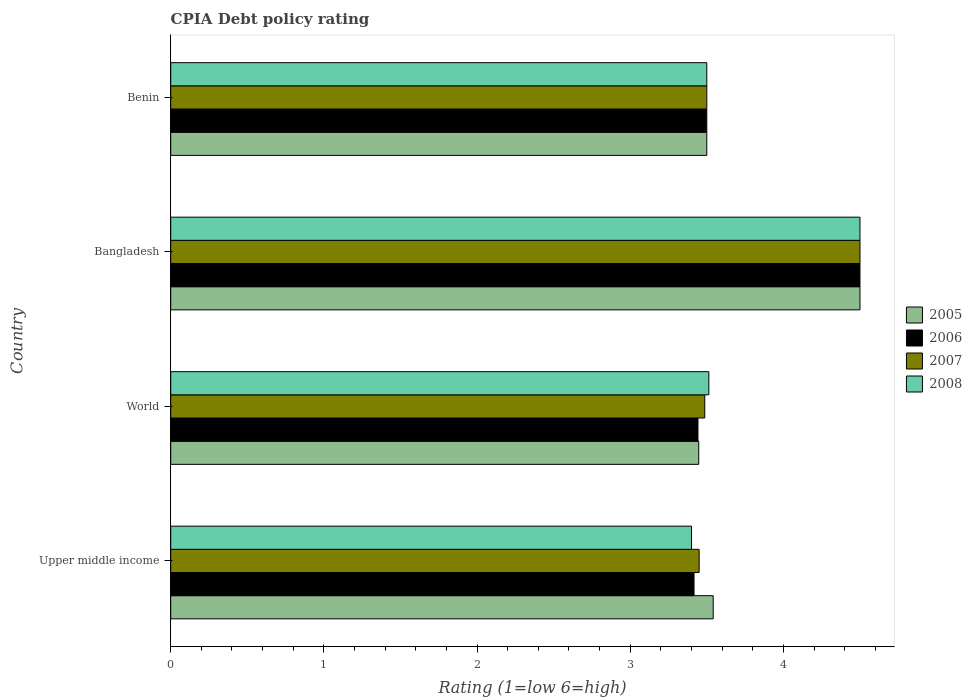How many groups of bars are there?
Provide a succinct answer. 4. Are the number of bars on each tick of the Y-axis equal?
Provide a succinct answer. Yes. What is the label of the 2nd group of bars from the top?
Keep it short and to the point. Bangladesh. What is the CPIA rating in 2007 in Benin?
Ensure brevity in your answer.  3.5. Across all countries, what is the maximum CPIA rating in 2005?
Offer a very short reply. 4.5. Across all countries, what is the minimum CPIA rating in 2007?
Provide a short and direct response. 3.45. In which country was the CPIA rating in 2007 minimum?
Provide a short and direct response. Upper middle income. What is the total CPIA rating in 2005 in the graph?
Provide a short and direct response. 14.99. What is the difference between the CPIA rating in 2005 in Upper middle income and that in World?
Keep it short and to the point. 0.09. What is the average CPIA rating in 2007 per country?
Your answer should be compact. 3.73. What is the difference between the CPIA rating in 2005 and CPIA rating in 2007 in Benin?
Ensure brevity in your answer.  0. What is the ratio of the CPIA rating in 2008 in Bangladesh to that in Benin?
Your answer should be very brief. 1.29. Is the difference between the CPIA rating in 2005 in Bangladesh and Benin greater than the difference between the CPIA rating in 2007 in Bangladesh and Benin?
Offer a very short reply. No. What is the difference between the highest and the second highest CPIA rating in 2008?
Provide a short and direct response. 0.99. What is the difference between the highest and the lowest CPIA rating in 2005?
Your response must be concise. 1.05. In how many countries, is the CPIA rating in 2007 greater than the average CPIA rating in 2007 taken over all countries?
Keep it short and to the point. 1. Is the sum of the CPIA rating in 2008 in Bangladesh and Upper middle income greater than the maximum CPIA rating in 2006 across all countries?
Give a very brief answer. Yes. What does the 1st bar from the top in Benin represents?
Provide a succinct answer. 2008. Is it the case that in every country, the sum of the CPIA rating in 2005 and CPIA rating in 2007 is greater than the CPIA rating in 2008?
Make the answer very short. Yes. How many bars are there?
Ensure brevity in your answer.  16. Are all the bars in the graph horizontal?
Give a very brief answer. Yes. How many countries are there in the graph?
Your response must be concise. 4. What is the difference between two consecutive major ticks on the X-axis?
Give a very brief answer. 1. Does the graph contain any zero values?
Give a very brief answer. No. Where does the legend appear in the graph?
Offer a terse response. Center right. How are the legend labels stacked?
Your answer should be compact. Vertical. What is the title of the graph?
Ensure brevity in your answer.  CPIA Debt policy rating. Does "2006" appear as one of the legend labels in the graph?
Make the answer very short. Yes. What is the Rating (1=low 6=high) of 2005 in Upper middle income?
Offer a very short reply. 3.54. What is the Rating (1=low 6=high) of 2006 in Upper middle income?
Make the answer very short. 3.42. What is the Rating (1=low 6=high) of 2007 in Upper middle income?
Your answer should be very brief. 3.45. What is the Rating (1=low 6=high) of 2005 in World?
Offer a terse response. 3.45. What is the Rating (1=low 6=high) of 2006 in World?
Keep it short and to the point. 3.44. What is the Rating (1=low 6=high) in 2007 in World?
Keep it short and to the point. 3.49. What is the Rating (1=low 6=high) of 2008 in World?
Provide a succinct answer. 3.51. What is the Rating (1=low 6=high) in 2005 in Bangladesh?
Your response must be concise. 4.5. What is the Rating (1=low 6=high) of 2006 in Bangladesh?
Keep it short and to the point. 4.5. What is the Rating (1=low 6=high) in 2007 in Bangladesh?
Your response must be concise. 4.5. What is the Rating (1=low 6=high) of 2005 in Benin?
Your answer should be very brief. 3.5. What is the Rating (1=low 6=high) of 2006 in Benin?
Provide a succinct answer. 3.5. What is the Rating (1=low 6=high) of 2008 in Benin?
Offer a terse response. 3.5. Across all countries, what is the minimum Rating (1=low 6=high) of 2005?
Your answer should be compact. 3.45. Across all countries, what is the minimum Rating (1=low 6=high) of 2006?
Your response must be concise. 3.42. Across all countries, what is the minimum Rating (1=low 6=high) of 2007?
Offer a very short reply. 3.45. What is the total Rating (1=low 6=high) of 2005 in the graph?
Make the answer very short. 14.99. What is the total Rating (1=low 6=high) of 2006 in the graph?
Provide a succinct answer. 14.86. What is the total Rating (1=low 6=high) of 2007 in the graph?
Your answer should be very brief. 14.94. What is the total Rating (1=low 6=high) in 2008 in the graph?
Offer a very short reply. 14.91. What is the difference between the Rating (1=low 6=high) of 2005 in Upper middle income and that in World?
Your answer should be compact. 0.09. What is the difference between the Rating (1=low 6=high) of 2006 in Upper middle income and that in World?
Offer a terse response. -0.03. What is the difference between the Rating (1=low 6=high) of 2007 in Upper middle income and that in World?
Your answer should be compact. -0.04. What is the difference between the Rating (1=low 6=high) in 2008 in Upper middle income and that in World?
Ensure brevity in your answer.  -0.11. What is the difference between the Rating (1=low 6=high) in 2005 in Upper middle income and that in Bangladesh?
Your answer should be very brief. -0.96. What is the difference between the Rating (1=low 6=high) of 2006 in Upper middle income and that in Bangladesh?
Give a very brief answer. -1.08. What is the difference between the Rating (1=low 6=high) of 2007 in Upper middle income and that in Bangladesh?
Offer a terse response. -1.05. What is the difference between the Rating (1=low 6=high) in 2008 in Upper middle income and that in Bangladesh?
Provide a short and direct response. -1.1. What is the difference between the Rating (1=low 6=high) in 2005 in Upper middle income and that in Benin?
Keep it short and to the point. 0.04. What is the difference between the Rating (1=low 6=high) in 2006 in Upper middle income and that in Benin?
Your answer should be very brief. -0.08. What is the difference between the Rating (1=low 6=high) in 2008 in Upper middle income and that in Benin?
Give a very brief answer. -0.1. What is the difference between the Rating (1=low 6=high) of 2005 in World and that in Bangladesh?
Keep it short and to the point. -1.05. What is the difference between the Rating (1=low 6=high) in 2006 in World and that in Bangladesh?
Your response must be concise. -1.06. What is the difference between the Rating (1=low 6=high) in 2007 in World and that in Bangladesh?
Offer a terse response. -1.01. What is the difference between the Rating (1=low 6=high) of 2008 in World and that in Bangladesh?
Provide a succinct answer. -0.99. What is the difference between the Rating (1=low 6=high) in 2005 in World and that in Benin?
Offer a terse response. -0.05. What is the difference between the Rating (1=low 6=high) of 2006 in World and that in Benin?
Offer a very short reply. -0.06. What is the difference between the Rating (1=low 6=high) in 2007 in World and that in Benin?
Ensure brevity in your answer.  -0.01. What is the difference between the Rating (1=low 6=high) in 2008 in World and that in Benin?
Your answer should be compact. 0.01. What is the difference between the Rating (1=low 6=high) in 2006 in Bangladesh and that in Benin?
Your answer should be compact. 1. What is the difference between the Rating (1=low 6=high) of 2008 in Bangladesh and that in Benin?
Provide a succinct answer. 1. What is the difference between the Rating (1=low 6=high) in 2005 in Upper middle income and the Rating (1=low 6=high) in 2006 in World?
Offer a terse response. 0.1. What is the difference between the Rating (1=low 6=high) of 2005 in Upper middle income and the Rating (1=low 6=high) of 2007 in World?
Provide a short and direct response. 0.06. What is the difference between the Rating (1=low 6=high) in 2005 in Upper middle income and the Rating (1=low 6=high) in 2008 in World?
Your answer should be compact. 0.03. What is the difference between the Rating (1=low 6=high) of 2006 in Upper middle income and the Rating (1=low 6=high) of 2007 in World?
Provide a succinct answer. -0.07. What is the difference between the Rating (1=low 6=high) in 2006 in Upper middle income and the Rating (1=low 6=high) in 2008 in World?
Provide a succinct answer. -0.1. What is the difference between the Rating (1=low 6=high) in 2007 in Upper middle income and the Rating (1=low 6=high) in 2008 in World?
Ensure brevity in your answer.  -0.06. What is the difference between the Rating (1=low 6=high) in 2005 in Upper middle income and the Rating (1=low 6=high) in 2006 in Bangladesh?
Provide a short and direct response. -0.96. What is the difference between the Rating (1=low 6=high) of 2005 in Upper middle income and the Rating (1=low 6=high) of 2007 in Bangladesh?
Your response must be concise. -0.96. What is the difference between the Rating (1=low 6=high) of 2005 in Upper middle income and the Rating (1=low 6=high) of 2008 in Bangladesh?
Provide a succinct answer. -0.96. What is the difference between the Rating (1=low 6=high) of 2006 in Upper middle income and the Rating (1=low 6=high) of 2007 in Bangladesh?
Offer a terse response. -1.08. What is the difference between the Rating (1=low 6=high) in 2006 in Upper middle income and the Rating (1=low 6=high) in 2008 in Bangladesh?
Offer a very short reply. -1.08. What is the difference between the Rating (1=low 6=high) of 2007 in Upper middle income and the Rating (1=low 6=high) of 2008 in Bangladesh?
Offer a very short reply. -1.05. What is the difference between the Rating (1=low 6=high) in 2005 in Upper middle income and the Rating (1=low 6=high) in 2006 in Benin?
Your answer should be very brief. 0.04. What is the difference between the Rating (1=low 6=high) of 2005 in Upper middle income and the Rating (1=low 6=high) of 2007 in Benin?
Ensure brevity in your answer.  0.04. What is the difference between the Rating (1=low 6=high) in 2005 in Upper middle income and the Rating (1=low 6=high) in 2008 in Benin?
Keep it short and to the point. 0.04. What is the difference between the Rating (1=low 6=high) of 2006 in Upper middle income and the Rating (1=low 6=high) of 2007 in Benin?
Your response must be concise. -0.08. What is the difference between the Rating (1=low 6=high) in 2006 in Upper middle income and the Rating (1=low 6=high) in 2008 in Benin?
Your answer should be very brief. -0.08. What is the difference between the Rating (1=low 6=high) in 2005 in World and the Rating (1=low 6=high) in 2006 in Bangladesh?
Your response must be concise. -1.05. What is the difference between the Rating (1=low 6=high) of 2005 in World and the Rating (1=low 6=high) of 2007 in Bangladesh?
Give a very brief answer. -1.05. What is the difference between the Rating (1=low 6=high) in 2005 in World and the Rating (1=low 6=high) in 2008 in Bangladesh?
Your answer should be very brief. -1.05. What is the difference between the Rating (1=low 6=high) of 2006 in World and the Rating (1=low 6=high) of 2007 in Bangladesh?
Keep it short and to the point. -1.06. What is the difference between the Rating (1=low 6=high) in 2006 in World and the Rating (1=low 6=high) in 2008 in Bangladesh?
Offer a terse response. -1.06. What is the difference between the Rating (1=low 6=high) in 2007 in World and the Rating (1=low 6=high) in 2008 in Bangladesh?
Offer a very short reply. -1.01. What is the difference between the Rating (1=low 6=high) of 2005 in World and the Rating (1=low 6=high) of 2006 in Benin?
Your answer should be compact. -0.05. What is the difference between the Rating (1=low 6=high) in 2005 in World and the Rating (1=low 6=high) in 2007 in Benin?
Offer a very short reply. -0.05. What is the difference between the Rating (1=low 6=high) of 2005 in World and the Rating (1=low 6=high) of 2008 in Benin?
Ensure brevity in your answer.  -0.05. What is the difference between the Rating (1=low 6=high) in 2006 in World and the Rating (1=low 6=high) in 2007 in Benin?
Keep it short and to the point. -0.06. What is the difference between the Rating (1=low 6=high) of 2006 in World and the Rating (1=low 6=high) of 2008 in Benin?
Provide a succinct answer. -0.06. What is the difference between the Rating (1=low 6=high) of 2007 in World and the Rating (1=low 6=high) of 2008 in Benin?
Your response must be concise. -0.01. What is the difference between the Rating (1=low 6=high) in 2005 in Bangladesh and the Rating (1=low 6=high) in 2008 in Benin?
Give a very brief answer. 1. What is the difference between the Rating (1=low 6=high) in 2006 in Bangladesh and the Rating (1=low 6=high) in 2008 in Benin?
Your answer should be compact. 1. What is the difference between the Rating (1=low 6=high) of 2007 in Bangladesh and the Rating (1=low 6=high) of 2008 in Benin?
Keep it short and to the point. 1. What is the average Rating (1=low 6=high) in 2005 per country?
Provide a short and direct response. 3.75. What is the average Rating (1=low 6=high) of 2006 per country?
Provide a succinct answer. 3.71. What is the average Rating (1=low 6=high) in 2007 per country?
Ensure brevity in your answer.  3.73. What is the average Rating (1=low 6=high) of 2008 per country?
Your response must be concise. 3.73. What is the difference between the Rating (1=low 6=high) in 2005 and Rating (1=low 6=high) in 2006 in Upper middle income?
Provide a succinct answer. 0.12. What is the difference between the Rating (1=low 6=high) of 2005 and Rating (1=low 6=high) of 2007 in Upper middle income?
Give a very brief answer. 0.09. What is the difference between the Rating (1=low 6=high) in 2005 and Rating (1=low 6=high) in 2008 in Upper middle income?
Your response must be concise. 0.14. What is the difference between the Rating (1=low 6=high) of 2006 and Rating (1=low 6=high) of 2007 in Upper middle income?
Your response must be concise. -0.03. What is the difference between the Rating (1=low 6=high) in 2006 and Rating (1=low 6=high) in 2008 in Upper middle income?
Your answer should be very brief. 0.02. What is the difference between the Rating (1=low 6=high) of 2005 and Rating (1=low 6=high) of 2006 in World?
Provide a succinct answer. 0.01. What is the difference between the Rating (1=low 6=high) of 2005 and Rating (1=low 6=high) of 2007 in World?
Give a very brief answer. -0.04. What is the difference between the Rating (1=low 6=high) of 2005 and Rating (1=low 6=high) of 2008 in World?
Ensure brevity in your answer.  -0.07. What is the difference between the Rating (1=low 6=high) in 2006 and Rating (1=low 6=high) in 2007 in World?
Keep it short and to the point. -0.04. What is the difference between the Rating (1=low 6=high) of 2006 and Rating (1=low 6=high) of 2008 in World?
Offer a very short reply. -0.07. What is the difference between the Rating (1=low 6=high) of 2007 and Rating (1=low 6=high) of 2008 in World?
Your answer should be very brief. -0.03. What is the difference between the Rating (1=low 6=high) of 2005 and Rating (1=low 6=high) of 2006 in Bangladesh?
Offer a very short reply. 0. What is the difference between the Rating (1=low 6=high) of 2005 and Rating (1=low 6=high) of 2008 in Bangladesh?
Give a very brief answer. 0. What is the difference between the Rating (1=low 6=high) in 2006 and Rating (1=low 6=high) in 2007 in Bangladesh?
Make the answer very short. 0. What is the difference between the Rating (1=low 6=high) in 2005 and Rating (1=low 6=high) in 2006 in Benin?
Make the answer very short. 0. What is the difference between the Rating (1=low 6=high) of 2006 and Rating (1=low 6=high) of 2008 in Benin?
Your response must be concise. 0. What is the difference between the Rating (1=low 6=high) of 2007 and Rating (1=low 6=high) of 2008 in Benin?
Give a very brief answer. 0. What is the ratio of the Rating (1=low 6=high) of 2005 in Upper middle income to that in World?
Give a very brief answer. 1.03. What is the ratio of the Rating (1=low 6=high) in 2007 in Upper middle income to that in World?
Provide a short and direct response. 0.99. What is the ratio of the Rating (1=low 6=high) of 2005 in Upper middle income to that in Bangladesh?
Offer a terse response. 0.79. What is the ratio of the Rating (1=low 6=high) in 2006 in Upper middle income to that in Bangladesh?
Give a very brief answer. 0.76. What is the ratio of the Rating (1=low 6=high) of 2007 in Upper middle income to that in Bangladesh?
Provide a short and direct response. 0.77. What is the ratio of the Rating (1=low 6=high) of 2008 in Upper middle income to that in Bangladesh?
Your answer should be compact. 0.76. What is the ratio of the Rating (1=low 6=high) of 2005 in Upper middle income to that in Benin?
Offer a terse response. 1.01. What is the ratio of the Rating (1=low 6=high) of 2006 in Upper middle income to that in Benin?
Make the answer very short. 0.98. What is the ratio of the Rating (1=low 6=high) of 2007 in Upper middle income to that in Benin?
Give a very brief answer. 0.99. What is the ratio of the Rating (1=low 6=high) in 2008 in Upper middle income to that in Benin?
Keep it short and to the point. 0.97. What is the ratio of the Rating (1=low 6=high) of 2005 in World to that in Bangladesh?
Keep it short and to the point. 0.77. What is the ratio of the Rating (1=low 6=high) in 2006 in World to that in Bangladesh?
Give a very brief answer. 0.77. What is the ratio of the Rating (1=low 6=high) in 2007 in World to that in Bangladesh?
Provide a succinct answer. 0.77. What is the ratio of the Rating (1=low 6=high) in 2008 in World to that in Bangladesh?
Your answer should be very brief. 0.78. What is the ratio of the Rating (1=low 6=high) in 2005 in World to that in Benin?
Your answer should be compact. 0.98. What is the ratio of the Rating (1=low 6=high) of 2006 in World to that in Benin?
Provide a short and direct response. 0.98. What is the ratio of the Rating (1=low 6=high) of 2007 in World to that in Benin?
Give a very brief answer. 1. What is the ratio of the Rating (1=low 6=high) in 2008 in World to that in Benin?
Provide a succinct answer. 1. What is the ratio of the Rating (1=low 6=high) in 2006 in Bangladesh to that in Benin?
Keep it short and to the point. 1.29. What is the ratio of the Rating (1=low 6=high) of 2007 in Bangladesh to that in Benin?
Offer a very short reply. 1.29. What is the difference between the highest and the second highest Rating (1=low 6=high) of 2007?
Keep it short and to the point. 1. What is the difference between the highest and the second highest Rating (1=low 6=high) in 2008?
Make the answer very short. 0.99. What is the difference between the highest and the lowest Rating (1=low 6=high) of 2005?
Your response must be concise. 1.05. What is the difference between the highest and the lowest Rating (1=low 6=high) of 2007?
Provide a succinct answer. 1.05. What is the difference between the highest and the lowest Rating (1=low 6=high) in 2008?
Your answer should be very brief. 1.1. 